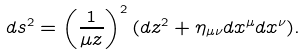Convert formula to latex. <formula><loc_0><loc_0><loc_500><loc_500>d s ^ { 2 } = \left ( \frac { 1 } { \mu z } \right ) ^ { 2 } ( d z ^ { 2 } + \eta _ { \mu \nu } d x ^ { \mu } d x ^ { \nu } ) .</formula> 